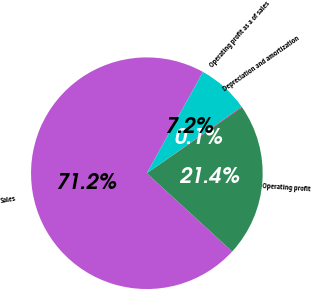<chart> <loc_0><loc_0><loc_500><loc_500><pie_chart><fcel>Sales<fcel>Operating profit<fcel>Depreciation and amortization<fcel>Operating profit as a of sales<nl><fcel>71.25%<fcel>21.44%<fcel>0.1%<fcel>7.21%<nl></chart> 